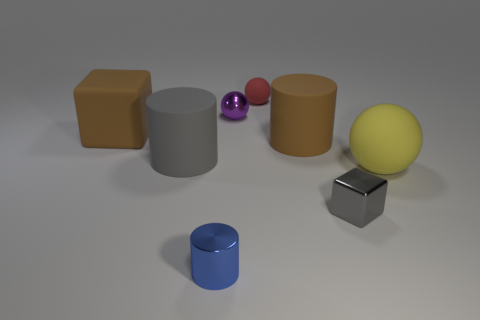Is the size of the cube that is behind the tiny gray cube the same as the rubber ball behind the large brown matte block?
Your answer should be compact. No. There is a large brown object that is the same shape as the tiny blue thing; what material is it?
Provide a short and direct response. Rubber. How many large objects are gray metallic blocks or brown rubber cubes?
Offer a terse response. 1. What material is the large gray cylinder?
Provide a succinct answer. Rubber. There is a ball that is right of the small purple thing and to the left of the big sphere; what is it made of?
Make the answer very short. Rubber. There is a tiny cylinder; is it the same color as the cube that is in front of the large brown rubber block?
Your answer should be very brief. No. There is a red sphere that is the same size as the metal cylinder; what material is it?
Your response must be concise. Rubber. Is there a yellow object made of the same material as the brown cylinder?
Provide a short and direct response. Yes. How many brown shiny cylinders are there?
Keep it short and to the point. 0. Does the large brown cylinder have the same material as the cylinder in front of the big yellow thing?
Your answer should be very brief. No. 